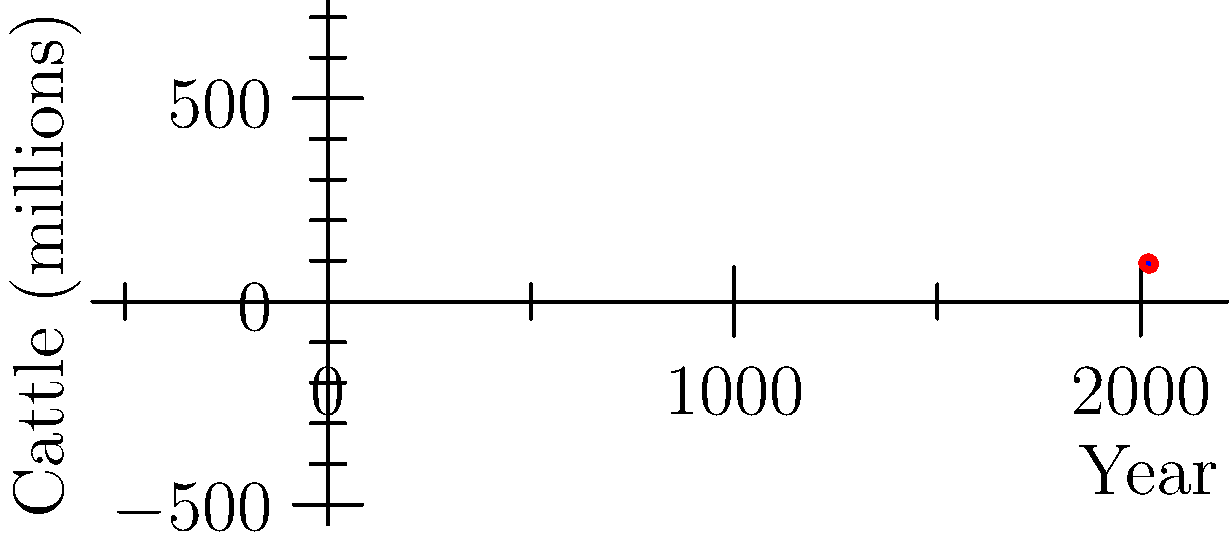As a cattle farmer, you've been tracking your herd size over the past few years. The scatter plot shows the U.S. cattle inventory from 2018 to 2022. Based on this trend, what would be your best estimate for the cattle inventory in 2023, assuming no major changes in market conditions or government regulations? To estimate the cattle inventory for 2023, we need to analyze the trend in the scatter plot:

1. Observe the overall trend: The cattle inventory is generally decreasing from 2018 to 2022.

2. Calculate the average yearly change:
   - 2018 to 2019: +0.5 million
   - 2019 to 2020: -1.2 million
   - 2020 to 2021: +0.2 million
   - 2021 to 2022: -1.9 million

3. Calculate the total change: 0.5 - 1.2 + 0.2 - 1.9 = -2.4 million

4. Calculate the average yearly change: -2.4 million / 4 years = -0.6 million per year

5. Apply the average yearly change to the 2022 value:
   91.9 million - 0.6 million = 91.3 million

Therefore, the best estimate for the cattle inventory in 2023 would be approximately 91.3 million head.
Answer: 91.3 million head 